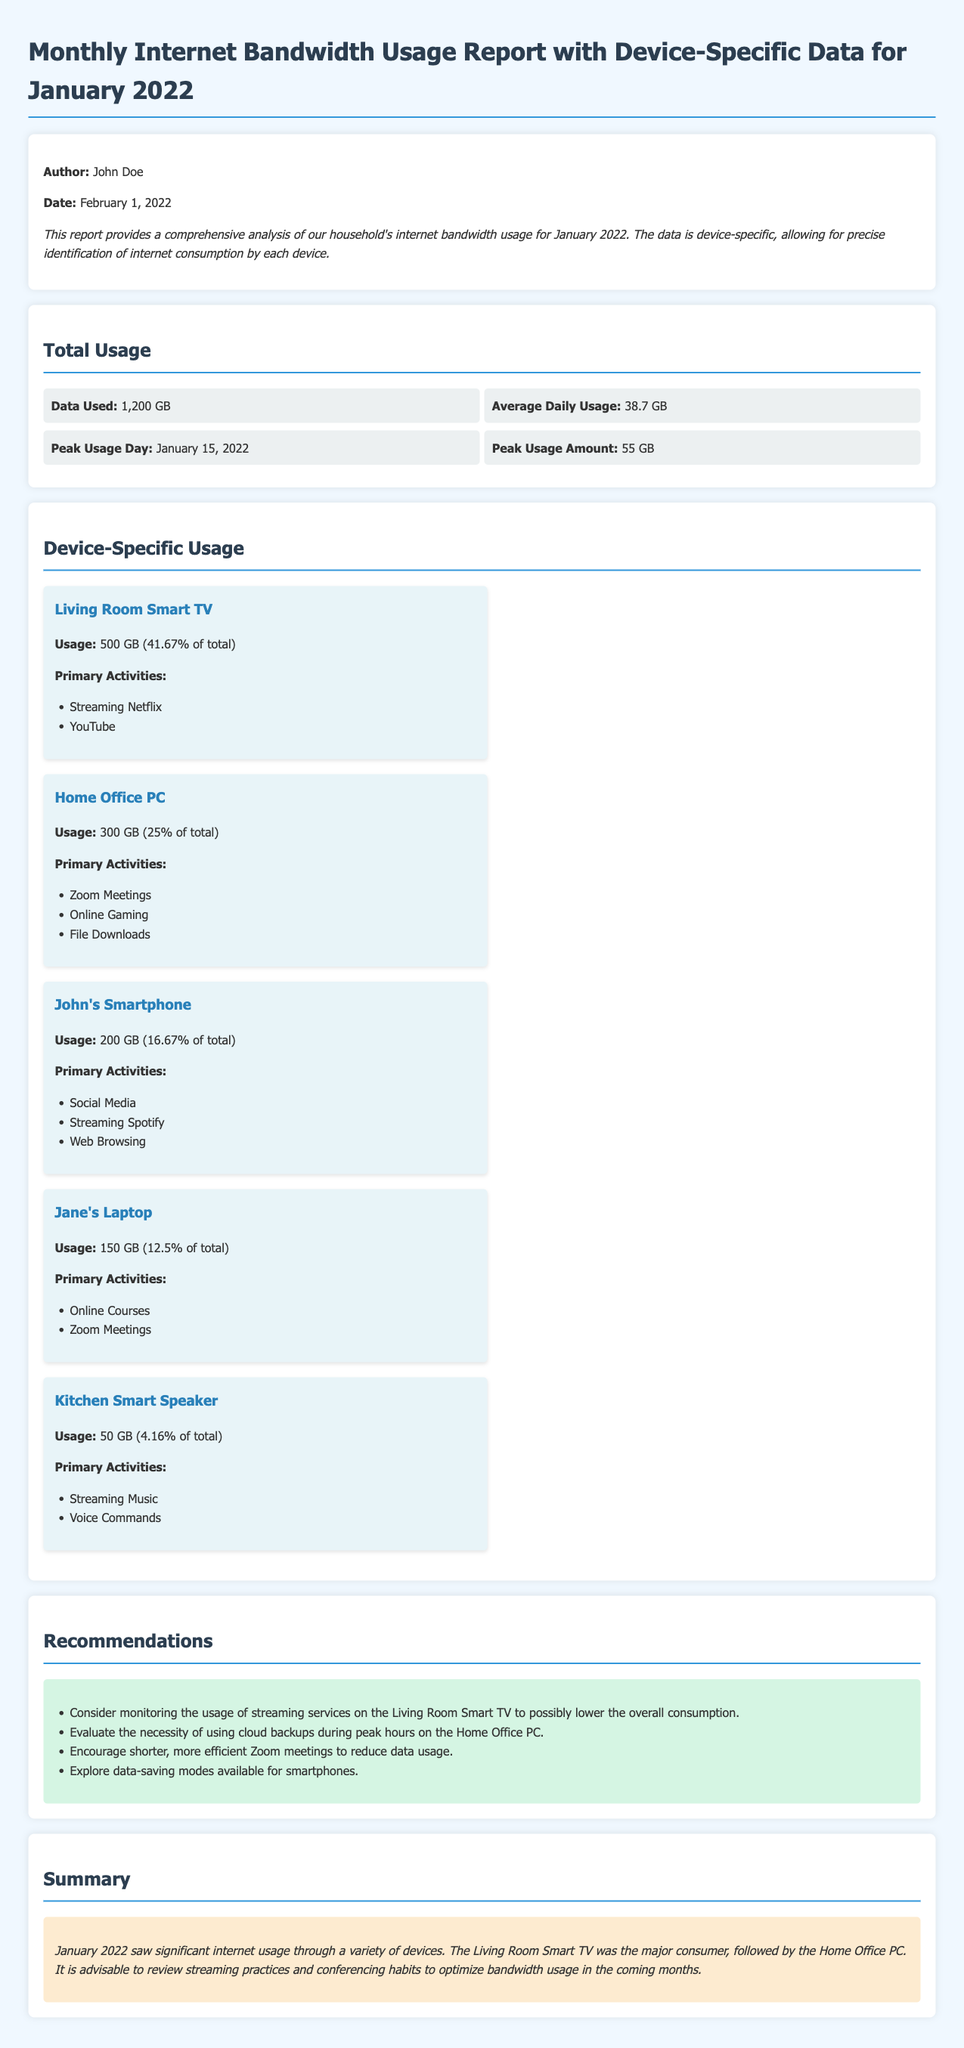What is the total data used in January 2022? The total data used is directly mentioned in the report under "Total Usage" as 1,200 GB.
Answer: 1,200 GB What was the average daily usage in January 2022? The report specifies that the average daily usage is calculated and stated as 38.7 GB.
Answer: 38.7 GB Which day had the peak usage and how much was it? The report indicates the peak usage day and amount together, stating January 15, 2022, with an amount of 55 GB.
Answer: January 15, 2022; 55 GB What is the usage percentage of the Living Room Smart TV? The report provides the usage of the Living Room Smart TV as 41.67% of the total usage figure.
Answer: 41.67% Which device had the lowest internet usage? By reviewing the device-specific usage, it is clear that the Kitchen Smart Speaker had the lowest usage of 50 GB.
Answer: Kitchen Smart Speaker What are the primary activities of Jane's Laptop? This device's primary activities are specified as online courses and Zoom meetings.
Answer: Online Courses, Zoom Meetings What recommendation is made regarding the Living Room Smart TV? The report recommends monitoring the usage of streaming services on this device to reduce overall consumption.
Answer: Monitor streaming services What is the author's name of the report? The report clearly states the author's name at the beginning as John Doe.
Answer: John Doe 